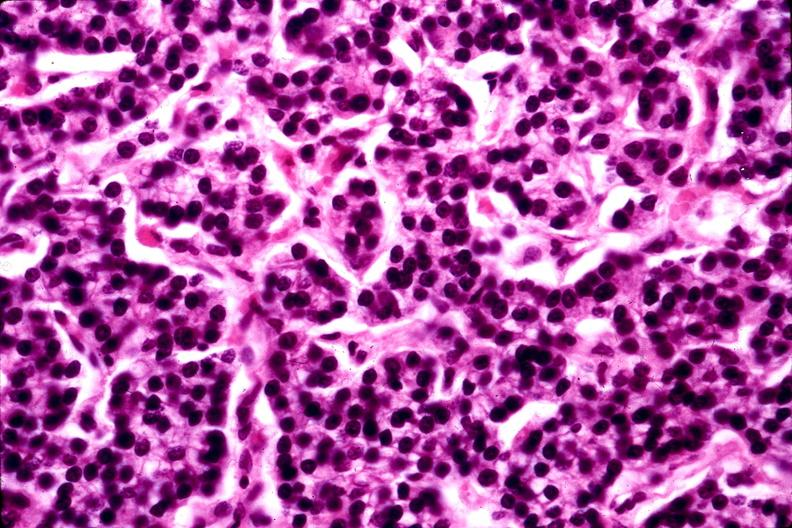s vessel present?
Answer the question using a single word or phrase. No 